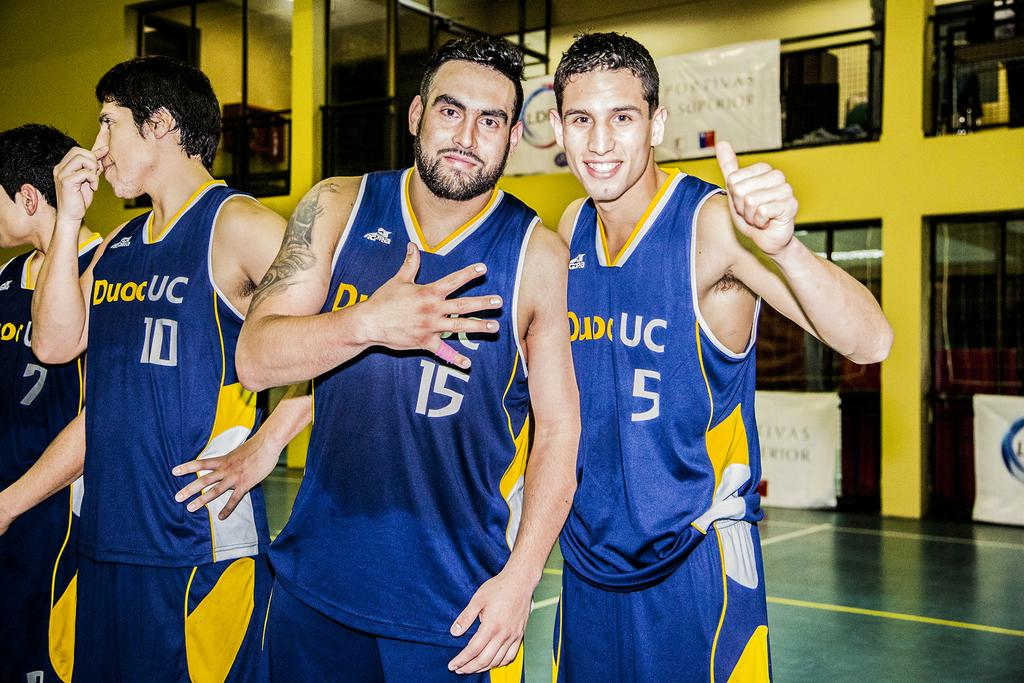How many people are in the image? There are persons standing in the image. What is the surface on which the persons are standing? The persons are standing on the floor. What additional object can be seen in the image? There is a banner in the image. How is the banner positioned in the image? The banner is attached to a fence. Where are the dolls placed in the image? There are no dolls present in the image. 